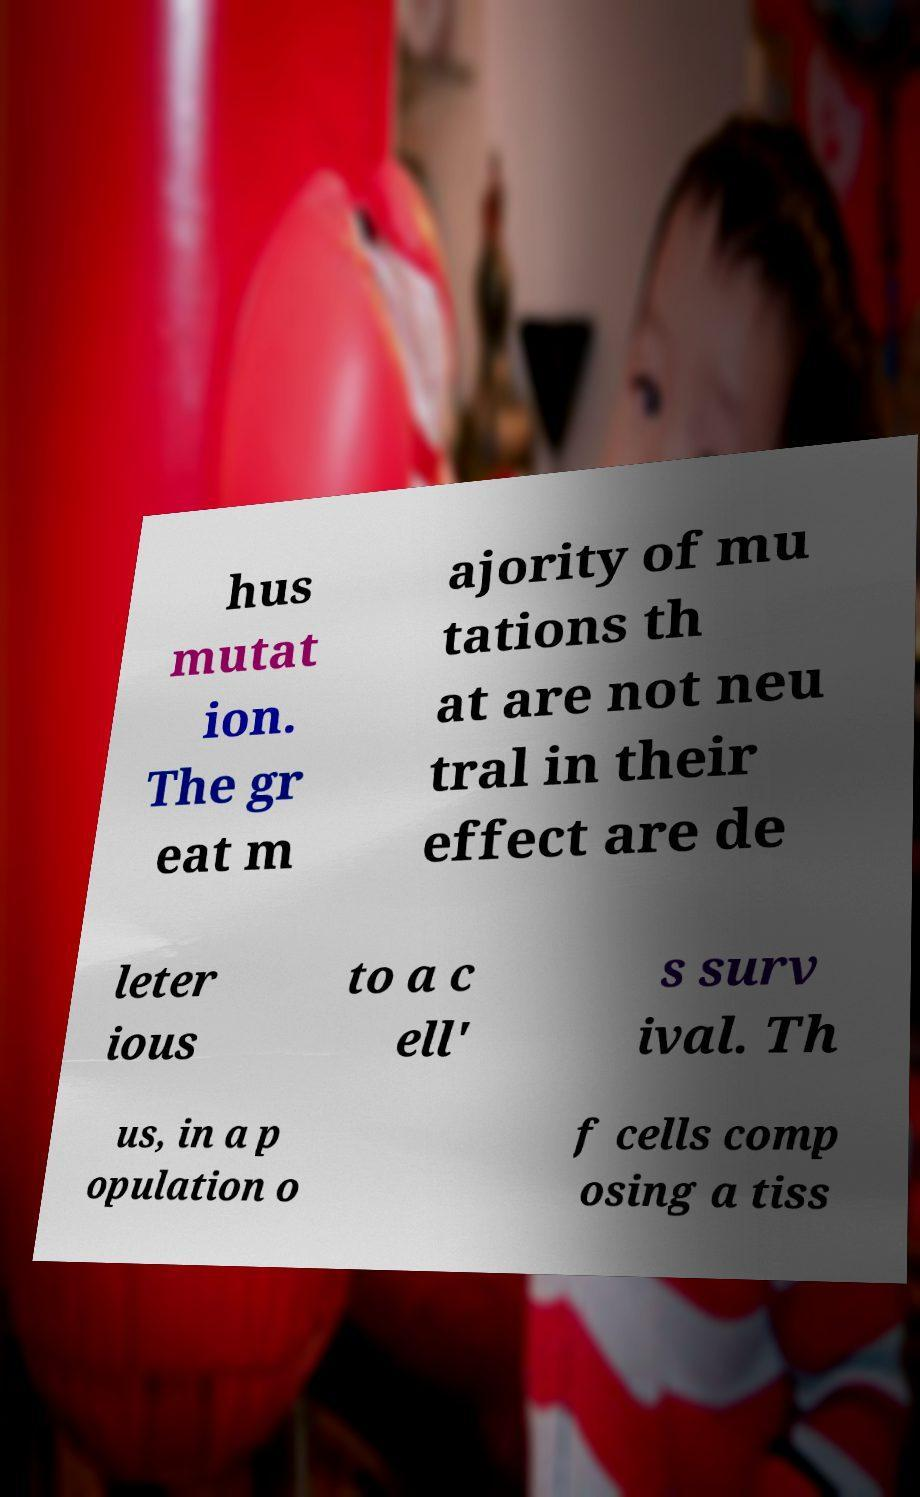Can you accurately transcribe the text from the provided image for me? hus mutat ion. The gr eat m ajority of mu tations th at are not neu tral in their effect are de leter ious to a c ell' s surv ival. Th us, in a p opulation o f cells comp osing a tiss 